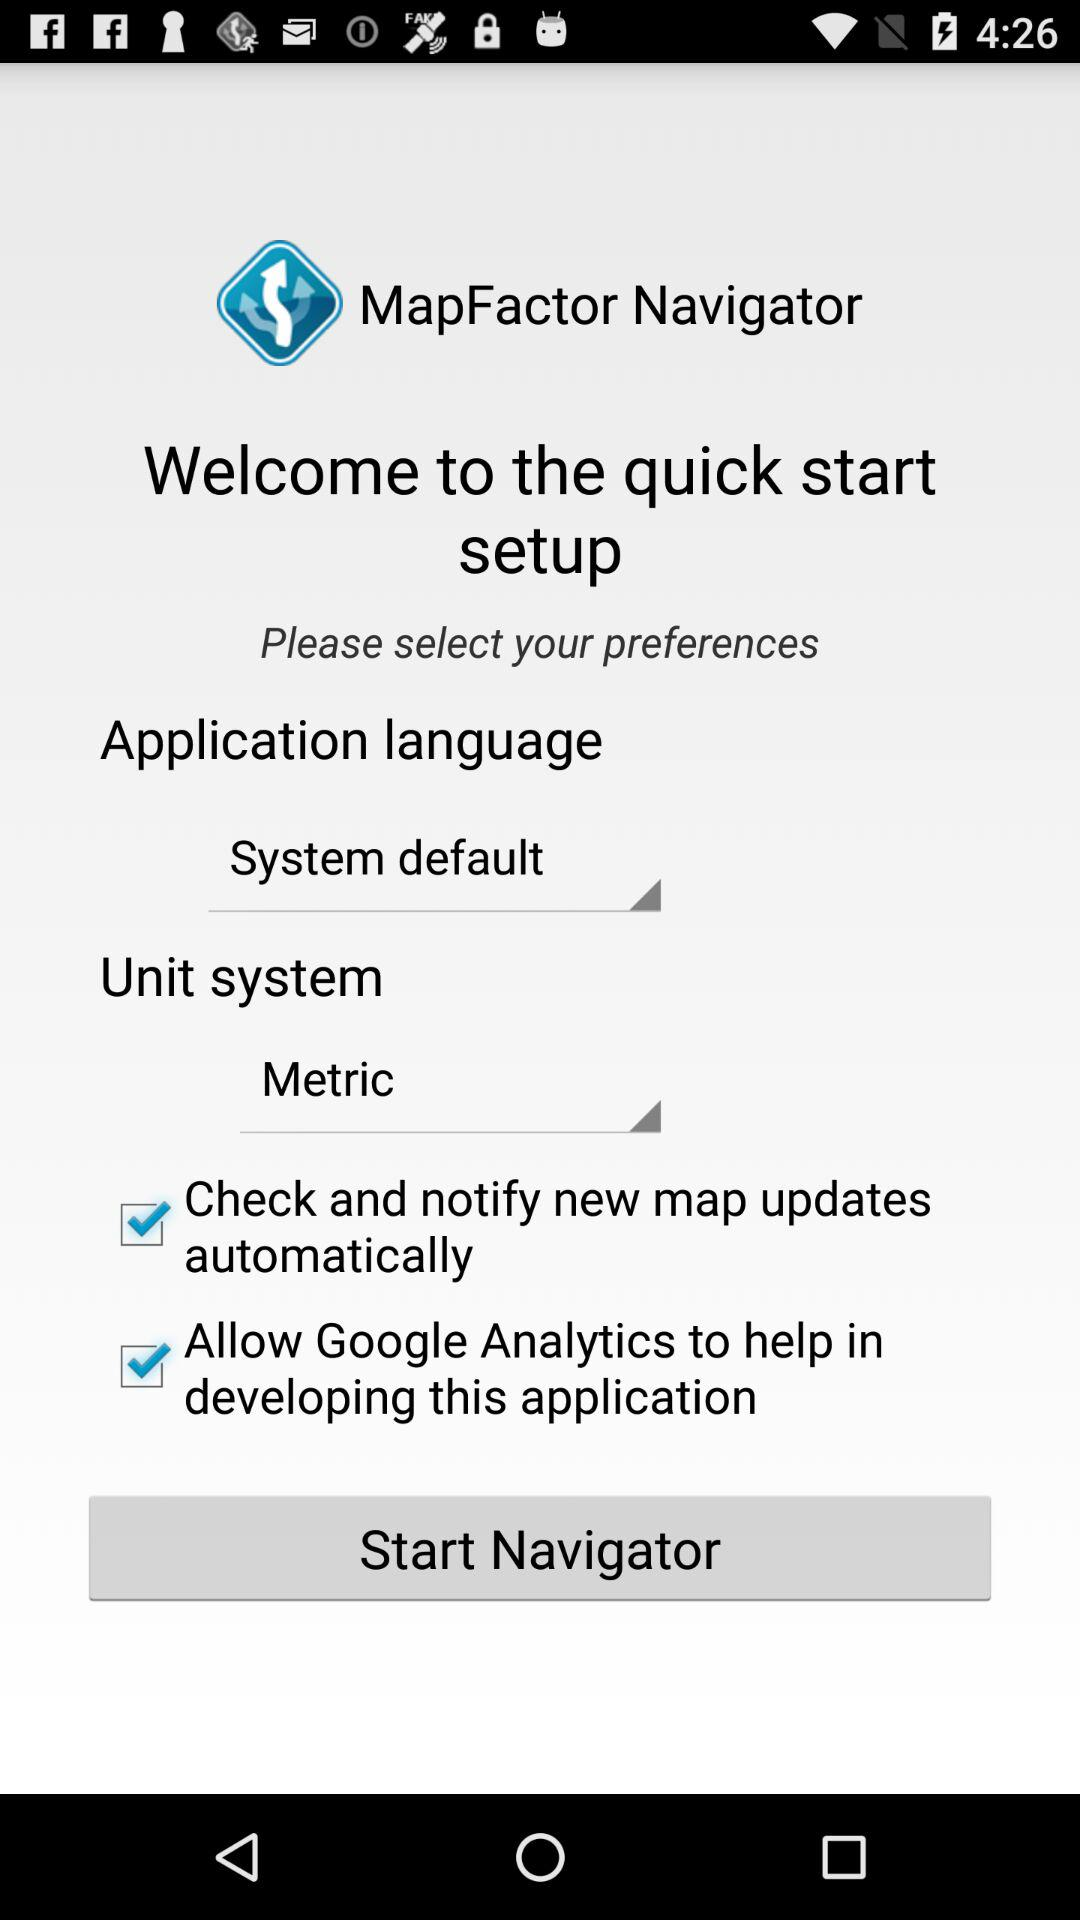What is the selected unit system? The selected unit system is "Metric". 